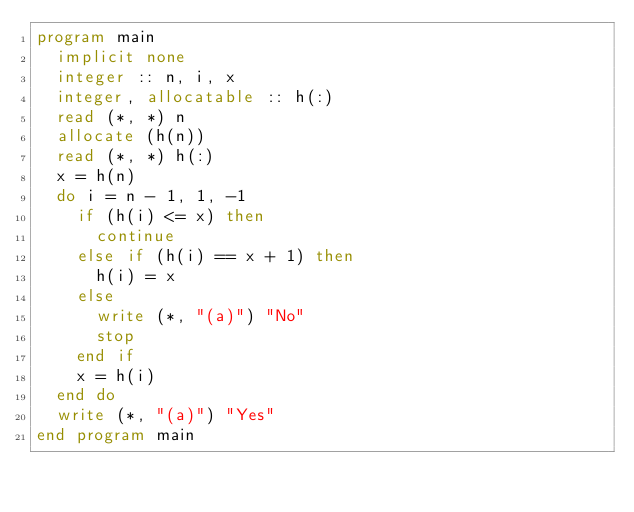<code> <loc_0><loc_0><loc_500><loc_500><_FORTRAN_>program main
  implicit none
  integer :: n, i, x
  integer, allocatable :: h(:)
  read (*, *) n
  allocate (h(n))
  read (*, *) h(:)
  x = h(n)
  do i = n - 1, 1, -1
    if (h(i) <= x) then
      continue
    else if (h(i) == x + 1) then
      h(i) = x
    else
      write (*, "(a)") "No"
      stop
    end if
    x = h(i)
  end do
  write (*, "(a)") "Yes"
end program main
</code> 